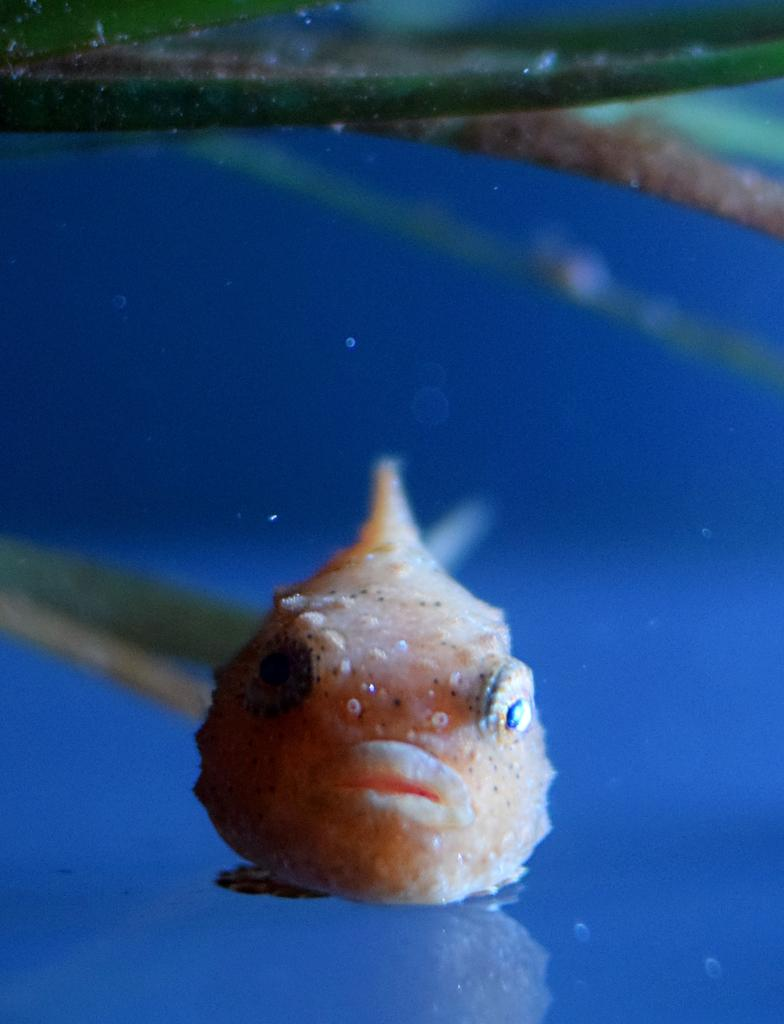What type of animals can be seen in the image? There are fish in the image. Where are the fish located? The fish are under water. What other objects or elements can be seen in the image? There are leaves in the image. What game is the man playing in the image? There is no man or game present in the image; it features fish under water and leaves. 